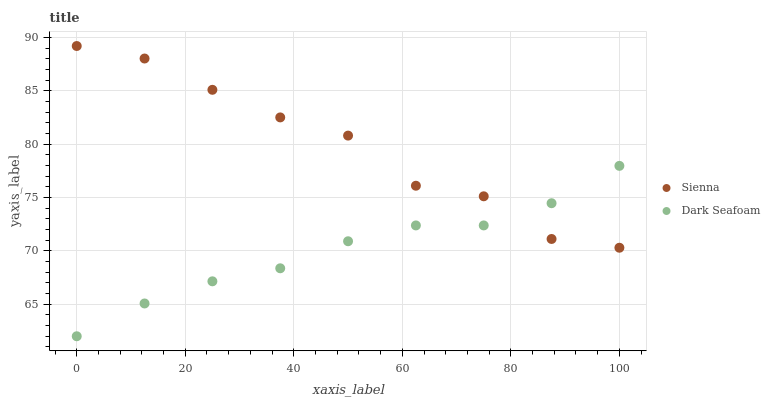Does Dark Seafoam have the minimum area under the curve?
Answer yes or no. Yes. Does Sienna have the maximum area under the curve?
Answer yes or no. Yes. Does Dark Seafoam have the maximum area under the curve?
Answer yes or no. No. Is Dark Seafoam the smoothest?
Answer yes or no. Yes. Is Sienna the roughest?
Answer yes or no. Yes. Is Dark Seafoam the roughest?
Answer yes or no. No. Does Dark Seafoam have the lowest value?
Answer yes or no. Yes. Does Sienna have the highest value?
Answer yes or no. Yes. Does Dark Seafoam have the highest value?
Answer yes or no. No. Does Sienna intersect Dark Seafoam?
Answer yes or no. Yes. Is Sienna less than Dark Seafoam?
Answer yes or no. No. Is Sienna greater than Dark Seafoam?
Answer yes or no. No. 